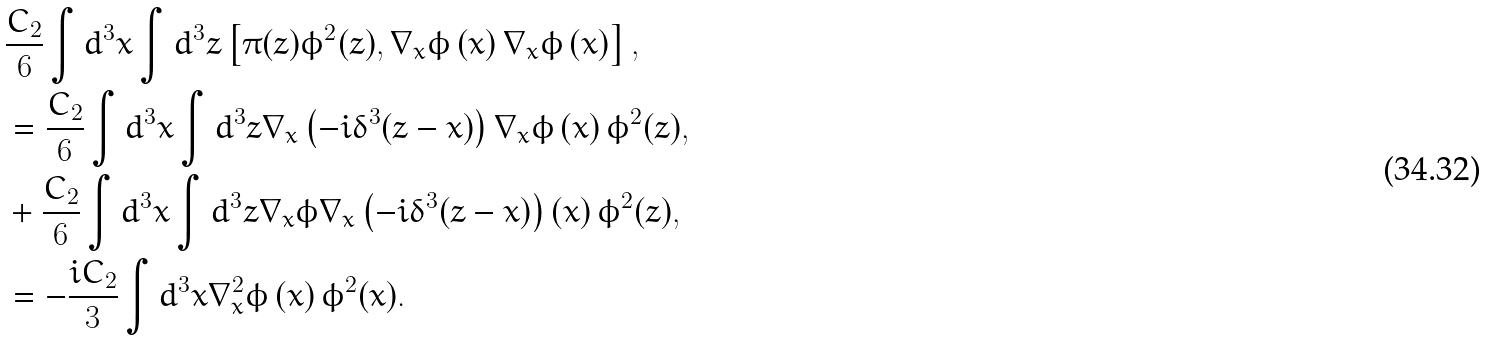<formula> <loc_0><loc_0><loc_500><loc_500>& \frac { C _ { 2 } } { 6 } \int d ^ { 3 } x \int d ^ { 3 } z \left [ \pi ( z ) \phi ^ { 2 } ( z ) , \nabla _ { x } \phi \left ( x \right ) \nabla _ { x } \phi \left ( x \right ) \right ] , \\ & = \frac { C _ { 2 } } { 6 } \int d ^ { 3 } x \int d ^ { 3 } z \nabla _ { x } \left ( - i \delta ^ { 3 } ( z - x ) \right ) \nabla _ { x } \phi \left ( x \right ) \phi ^ { 2 } ( z ) , \\ & + \frac { C _ { 2 } } { 6 } \int d ^ { 3 } x \int d ^ { 3 } z \nabla _ { x } \phi \nabla _ { x } \left ( - i \delta ^ { 3 } ( z - x ) \right ) \left ( x \right ) \phi ^ { 2 } ( z ) , \\ & = - \frac { i C _ { 2 } } { 3 } \int d ^ { 3 } x \nabla _ { x } ^ { 2 } \phi \left ( x \right ) \phi ^ { 2 } ( x ) .</formula> 